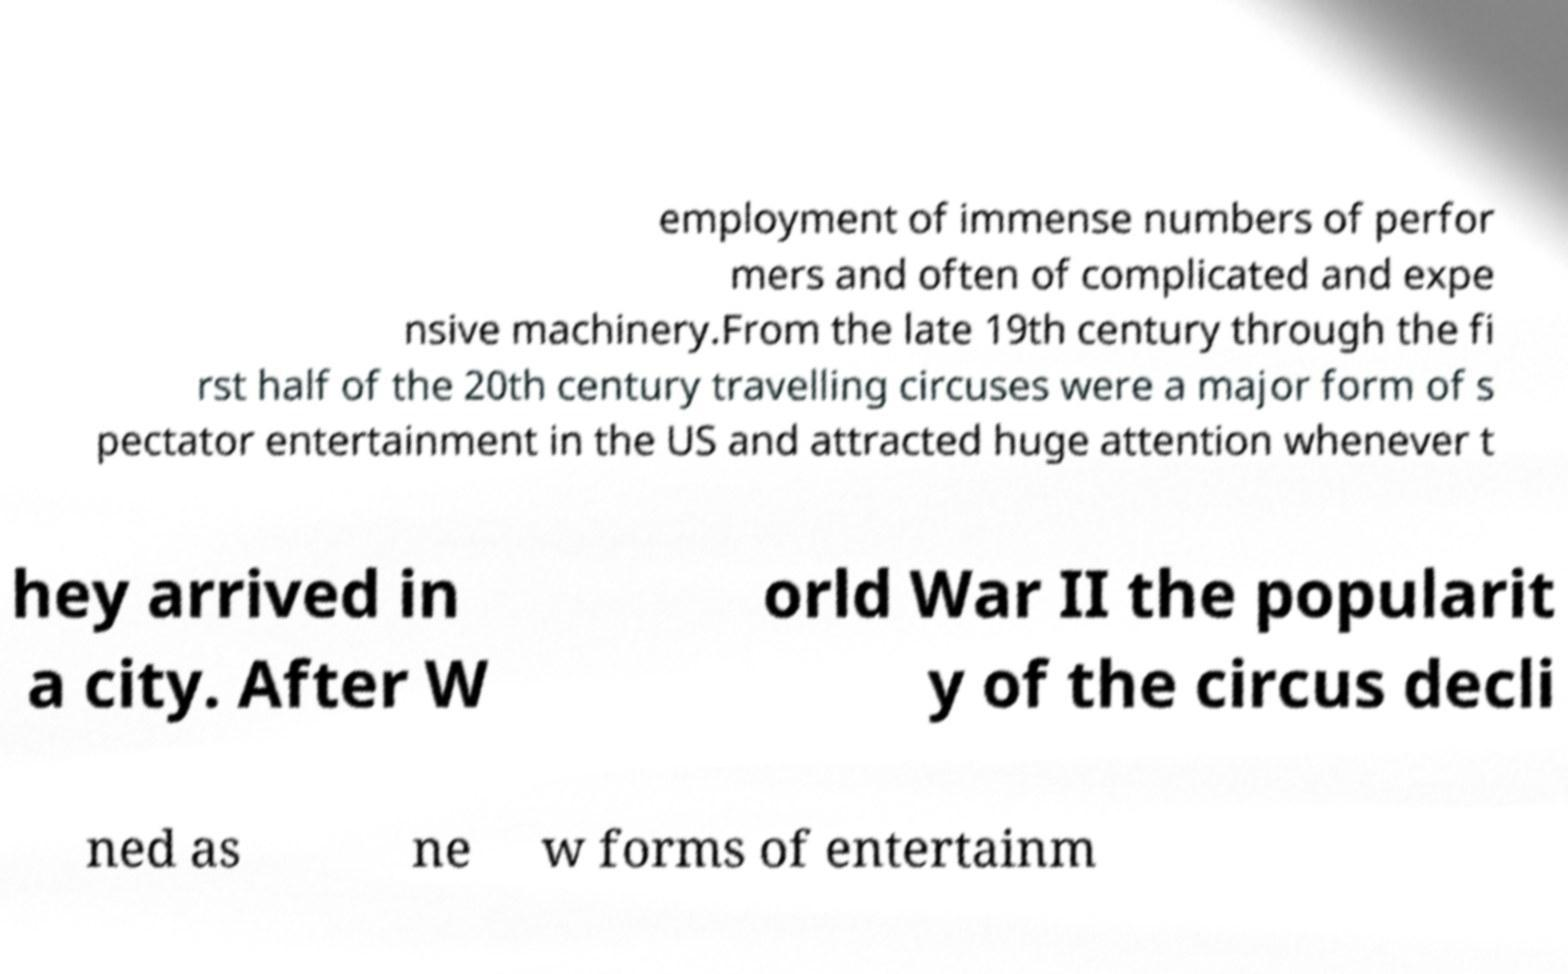Can you read and provide the text displayed in the image?This photo seems to have some interesting text. Can you extract and type it out for me? employment of immense numbers of perfor mers and often of complicated and expe nsive machinery.From the late 19th century through the fi rst half of the 20th century travelling circuses were a major form of s pectator entertainment in the US and attracted huge attention whenever t hey arrived in a city. After W orld War II the popularit y of the circus decli ned as ne w forms of entertainm 